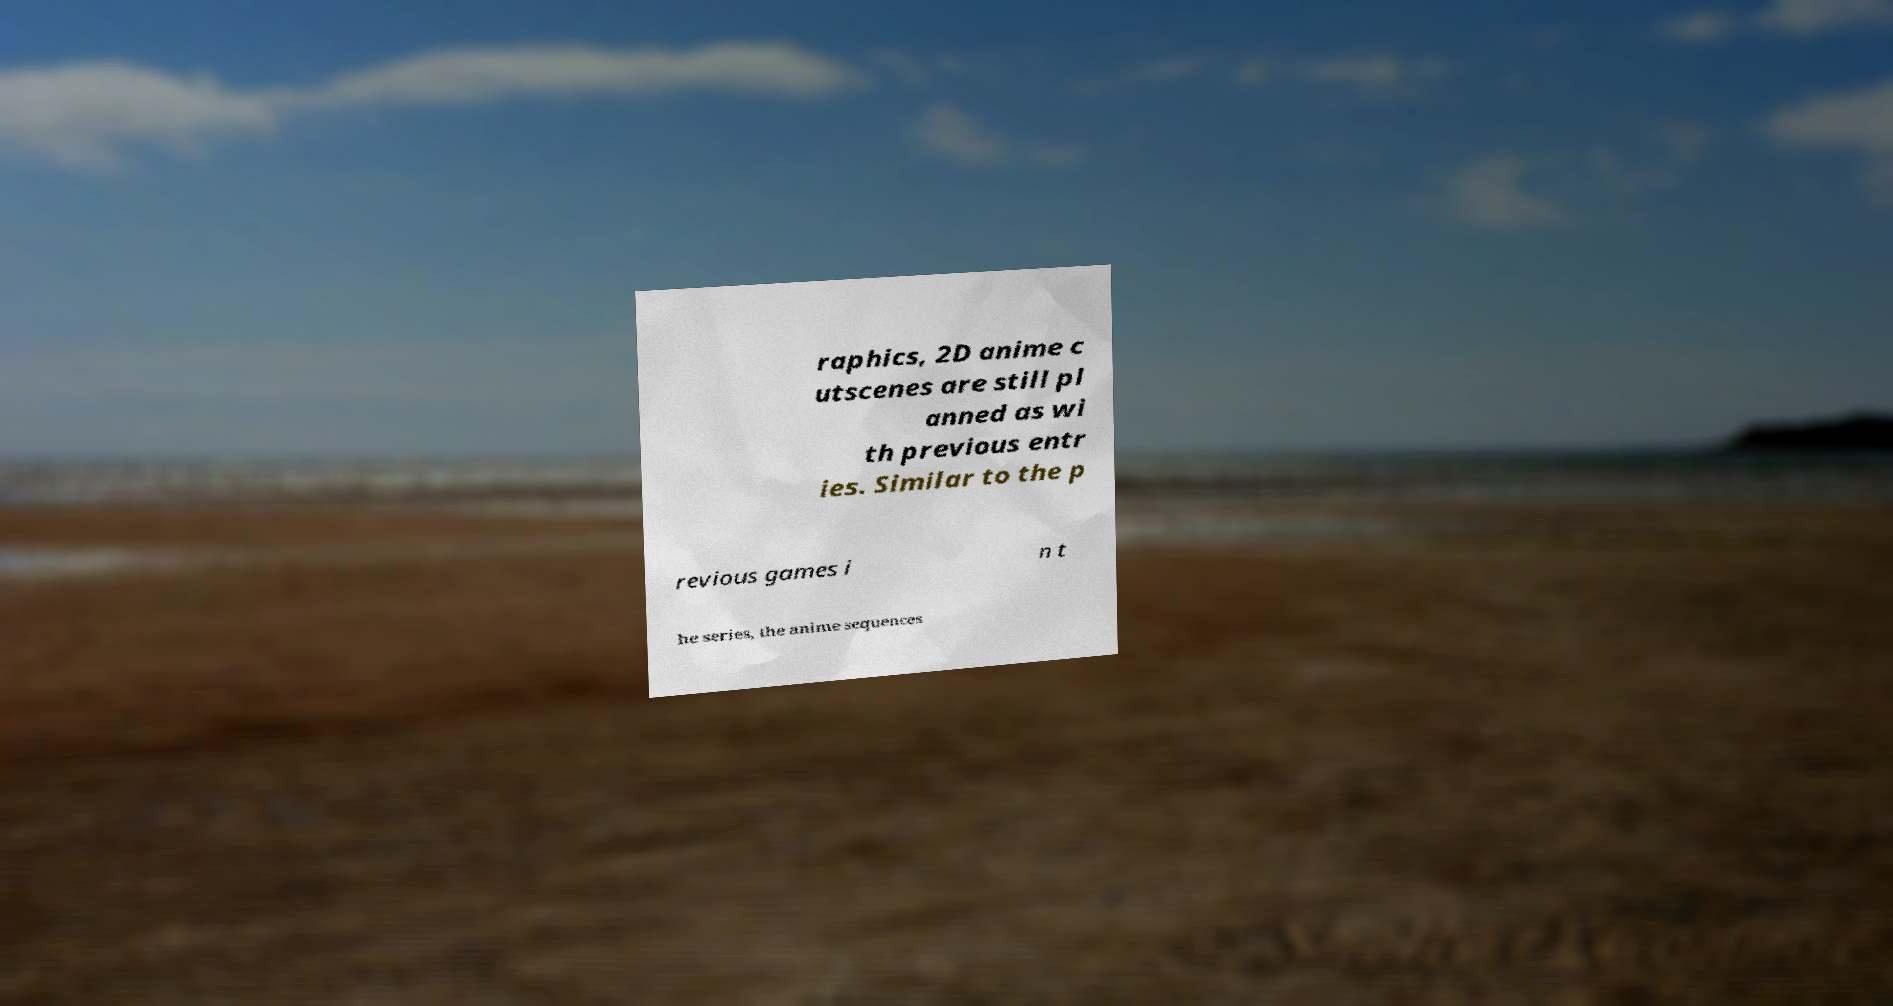Please read and relay the text visible in this image. What does it say? raphics, 2D anime c utscenes are still pl anned as wi th previous entr ies. Similar to the p revious games i n t he series, the anime sequences 